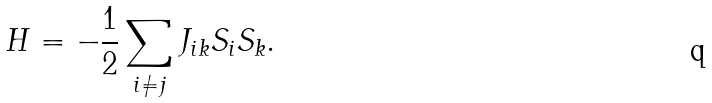<formula> <loc_0><loc_0><loc_500><loc_500>H = - \frac { 1 } { 2 } \sum _ { i \neq j } J _ { i k } S _ { i } S _ { k } .</formula> 